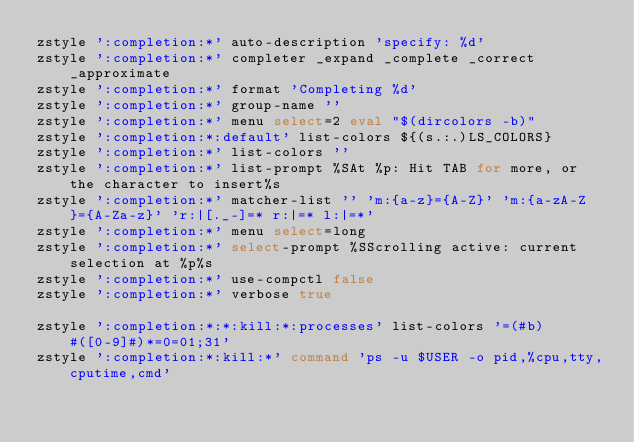<code> <loc_0><loc_0><loc_500><loc_500><_Bash_>zstyle ':completion:*' auto-description 'specify: %d'
zstyle ':completion:*' completer _expand _complete _correct _approximate
zstyle ':completion:*' format 'Completing %d'
zstyle ':completion:*' group-name ''
zstyle ':completion:*' menu select=2 eval "$(dircolors -b)"
zstyle ':completion:*:default' list-colors ${(s.:.)LS_COLORS}
zstyle ':completion:*' list-colors ''
zstyle ':completion:*' list-prompt %SAt %p: Hit TAB for more, or the character to insert%s
zstyle ':completion:*' matcher-list '' 'm:{a-z}={A-Z}' 'm:{a-zA-Z}={A-Za-z}' 'r:|[._-]=* r:|=* l:|=*'
zstyle ':completion:*' menu select=long
zstyle ':completion:*' select-prompt %SScrolling active: current selection at %p%s
zstyle ':completion:*' use-compctl false
zstyle ':completion:*' verbose true

zstyle ':completion:*:*:kill:*:processes' list-colors '=(#b) #([0-9]#)*=0=01;31'
zstyle ':completion:*:kill:*' command 'ps -u $USER -o pid,%cpu,tty,cputime,cmd'

</code> 